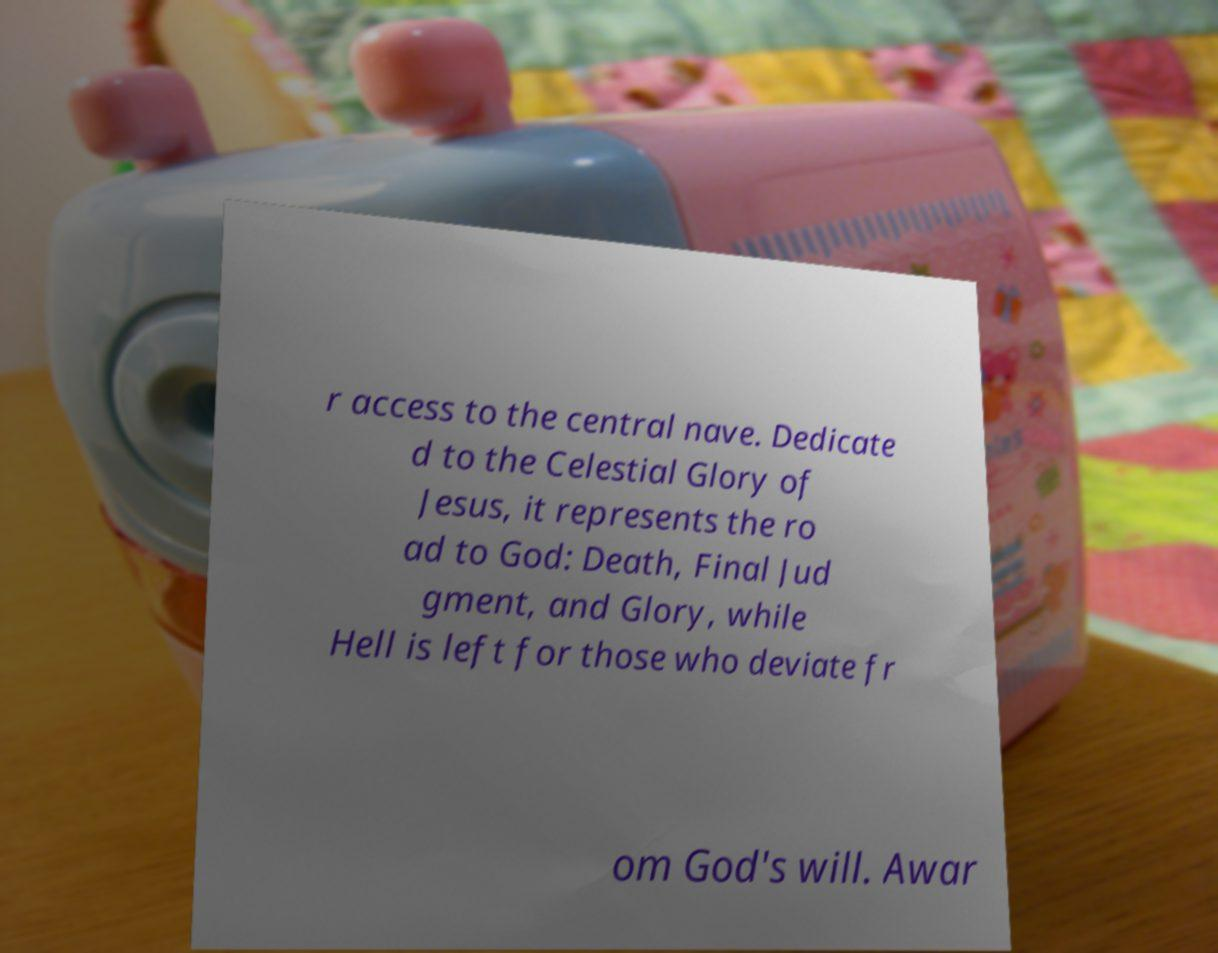What messages or text are displayed in this image? I need them in a readable, typed format. r access to the central nave. Dedicate d to the Celestial Glory of Jesus, it represents the ro ad to God: Death, Final Jud gment, and Glory, while Hell is left for those who deviate fr om God's will. Awar 